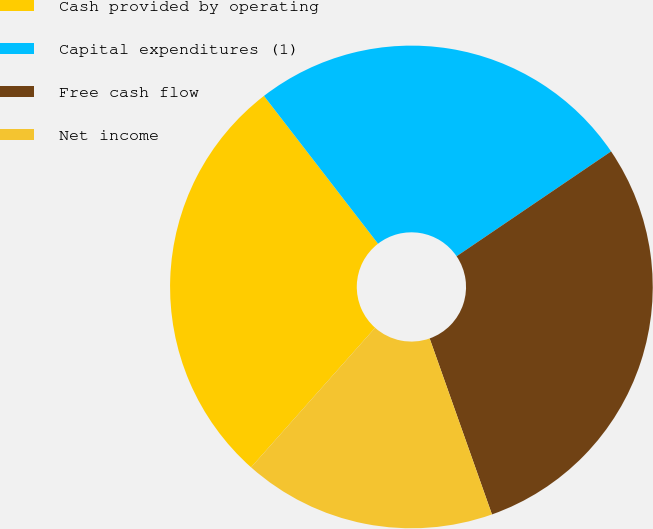Convert chart. <chart><loc_0><loc_0><loc_500><loc_500><pie_chart><fcel>Cash provided by operating<fcel>Capital expenditures (1)<fcel>Free cash flow<fcel>Net income<nl><fcel>27.97%<fcel>25.97%<fcel>29.07%<fcel>16.98%<nl></chart> 